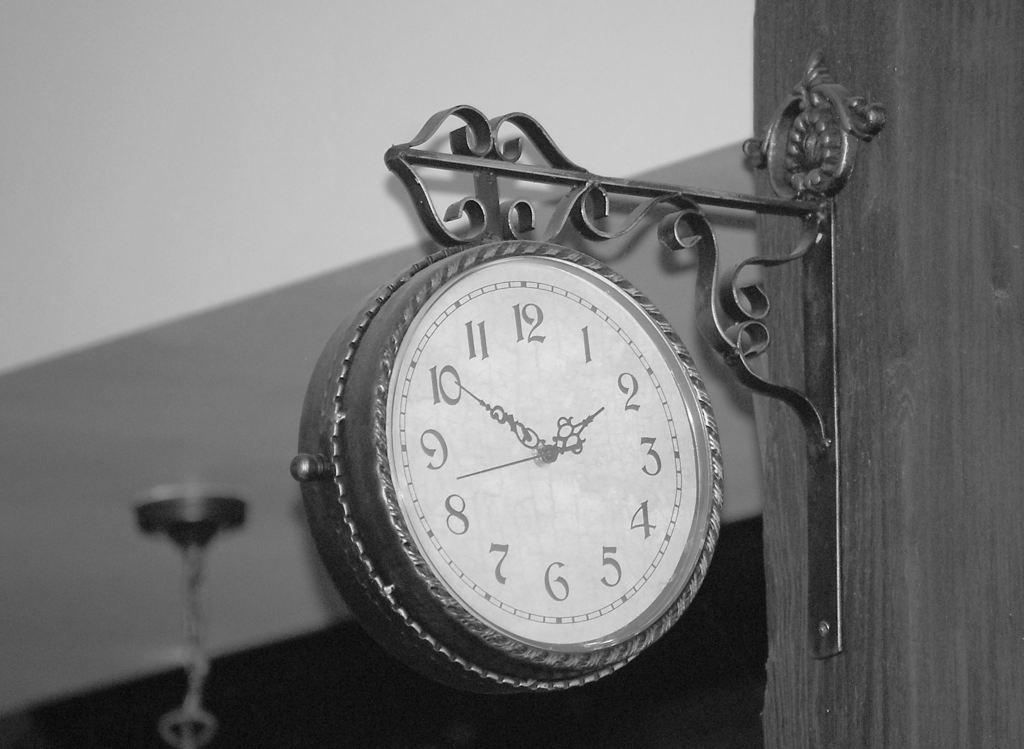What is the main object in the image? There is a clock in the image. Can you describe anything behind the clock? There is an object behind the clock, but its details are not clear from the image. What can be seen in the background of the image? There is a wall in the background of the image. What story is the mother telling in the class in the image? There is no mother or class present in the image; it only features a clock and an object behind it. 